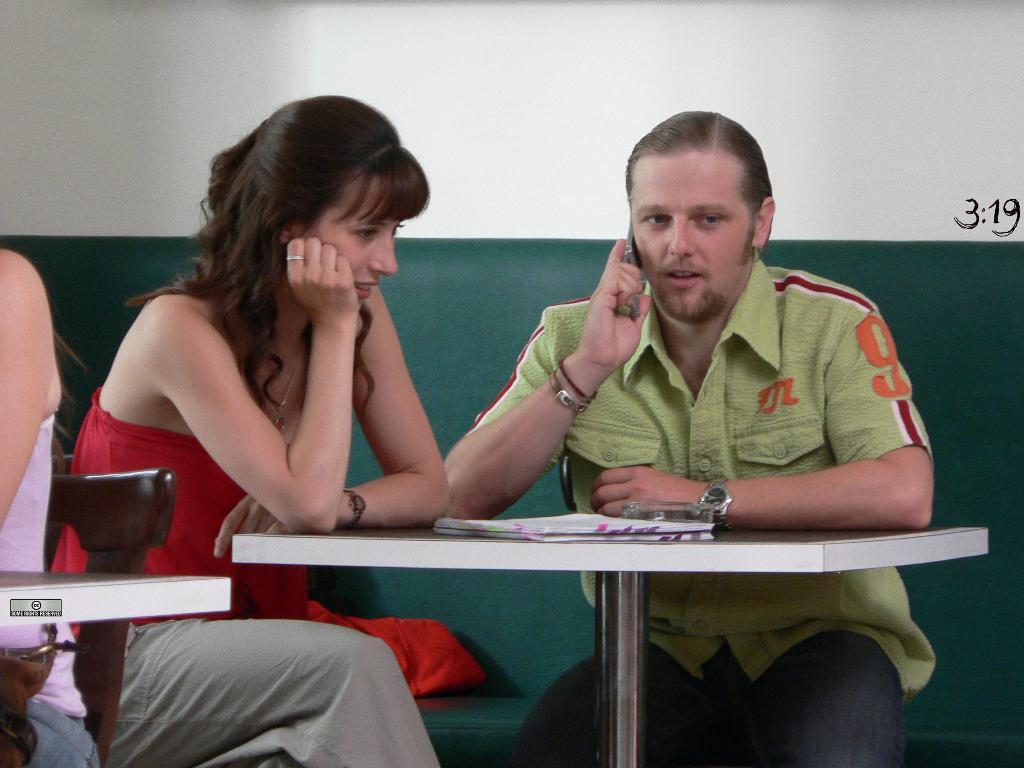How many people are present in the image? There are two people sitting in the image. What is the color of the table in the image? There is a white table in the image. What object can be seen on the table? There is a book on the table. What color is the wall in the background of the image? There is a green color wall in the background. What can be seen on the wall in the image? There is a red color object on the wall. What type of tank is visible in the image? There is no tank present in the image. What need is being fulfilled by the people in the image? The image does not provide information about the needs of the people, so it cannot be determined from the image. 